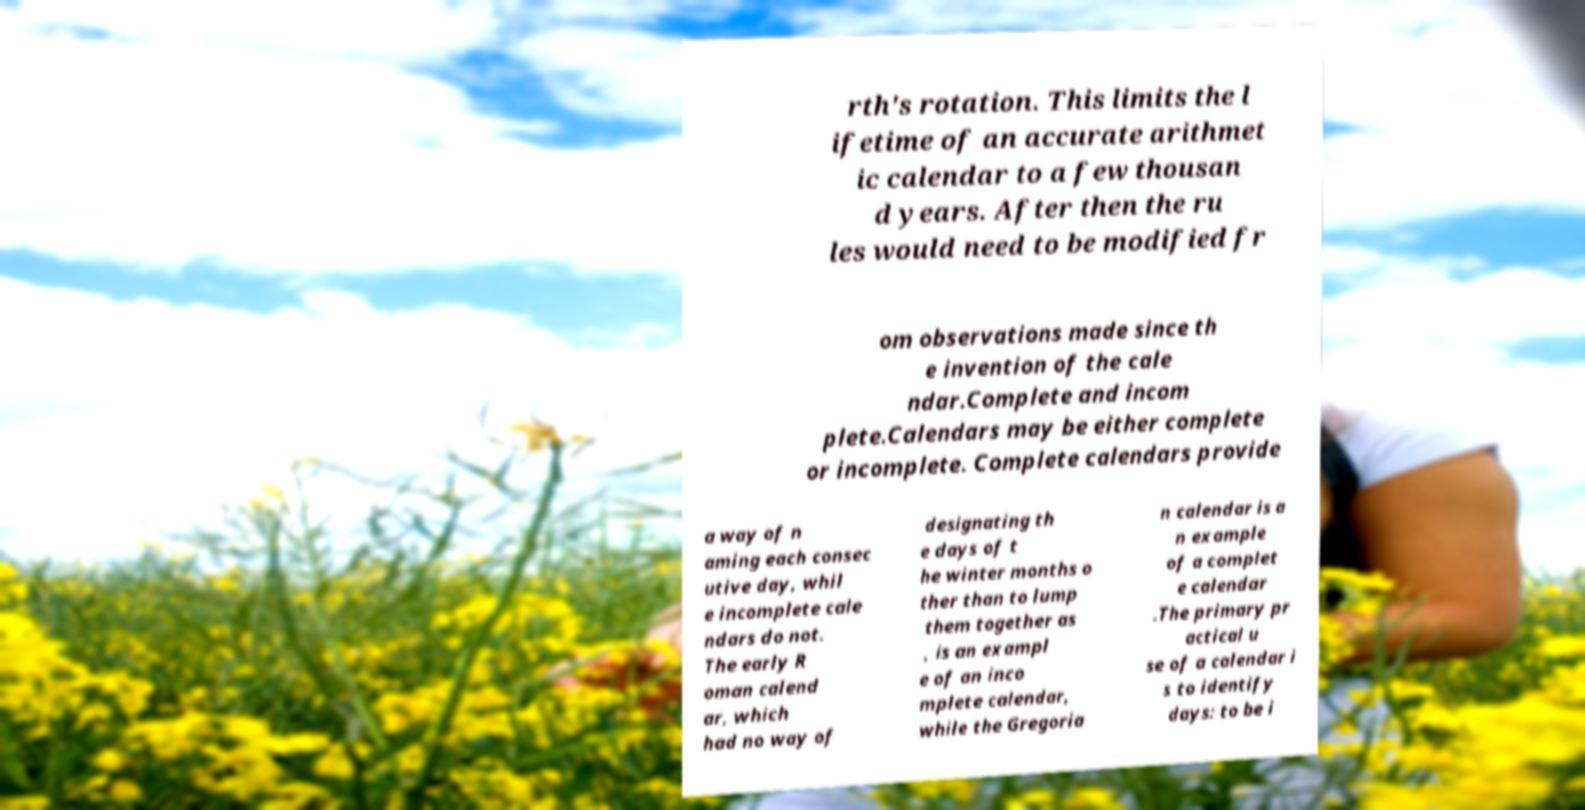Can you accurately transcribe the text from the provided image for me? rth's rotation. This limits the l ifetime of an accurate arithmet ic calendar to a few thousan d years. After then the ru les would need to be modified fr om observations made since th e invention of the cale ndar.Complete and incom plete.Calendars may be either complete or incomplete. Complete calendars provide a way of n aming each consec utive day, whil e incomplete cale ndars do not. The early R oman calend ar, which had no way of designating th e days of t he winter months o ther than to lump them together as , is an exampl e of an inco mplete calendar, while the Gregoria n calendar is a n example of a complet e calendar .The primary pr actical u se of a calendar i s to identify days: to be i 